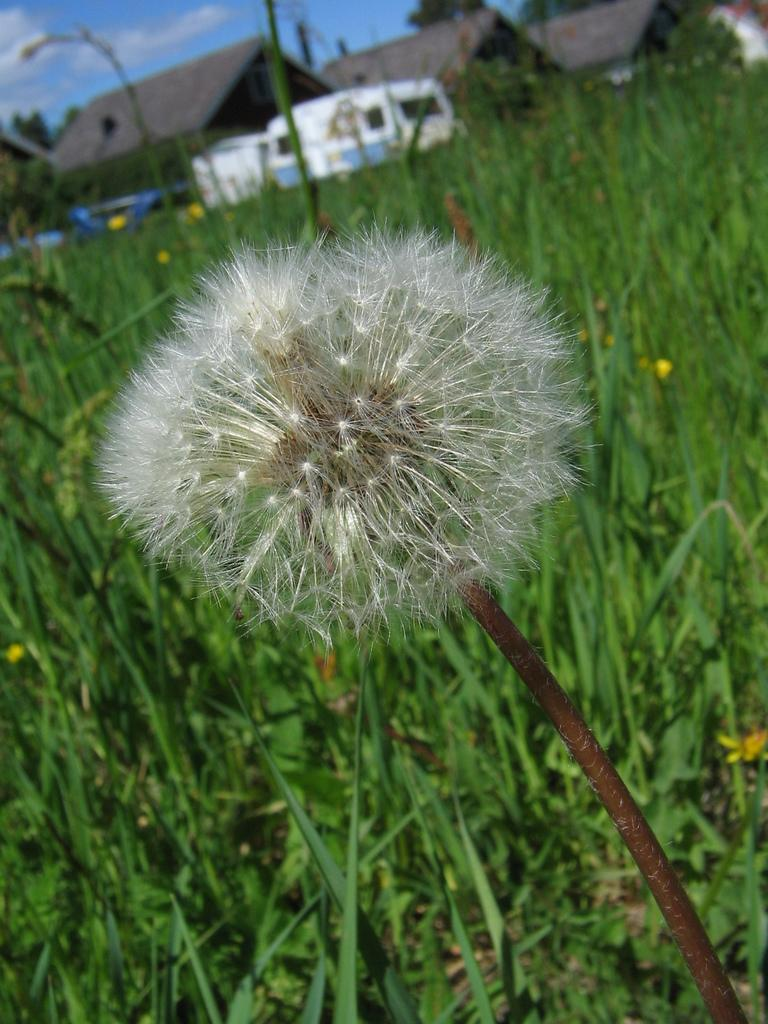What is located at the bottom right of the image? There is a flower at the bottom right of the image. What else can be seen at the bottom of the image? There are plants visible at the bottom of the image. What structures are visible at the top of the image? There are buildings visible at the top of the image. What type of vegetation is present in the top part of the image? There are trees in the top part of the image. What is visible in the sky at the top of the image? The sky is visible at the top of the image. Can you hear the goldfish swimming in the image? There are no goldfish present in the image, so it is not possible to hear them swimming. What type of beam is holding up the buildings in the image? There is no specific beam mentioned or visible in the image, so it is not possible to identify the type of beam. 